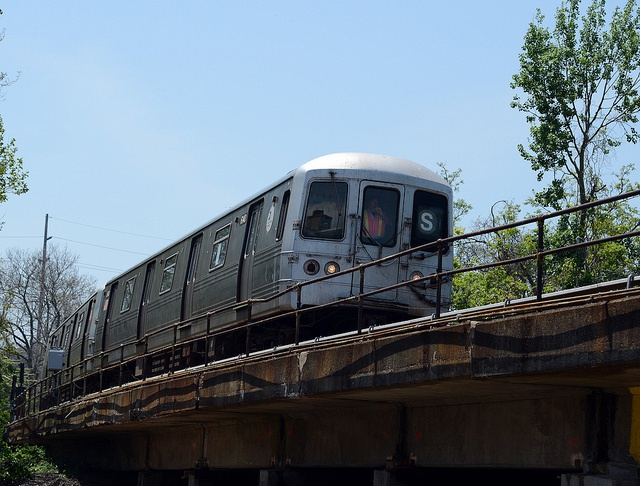Describe the objects in this image and their specific colors. I can see train in lightblue, black, gray, and darkblue tones and people in lightblue, black, and purple tones in this image. 